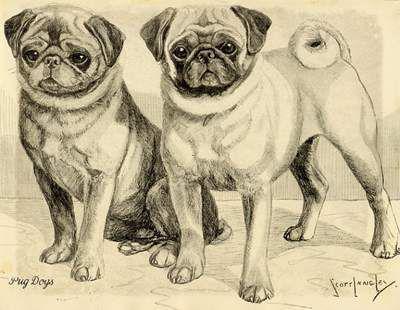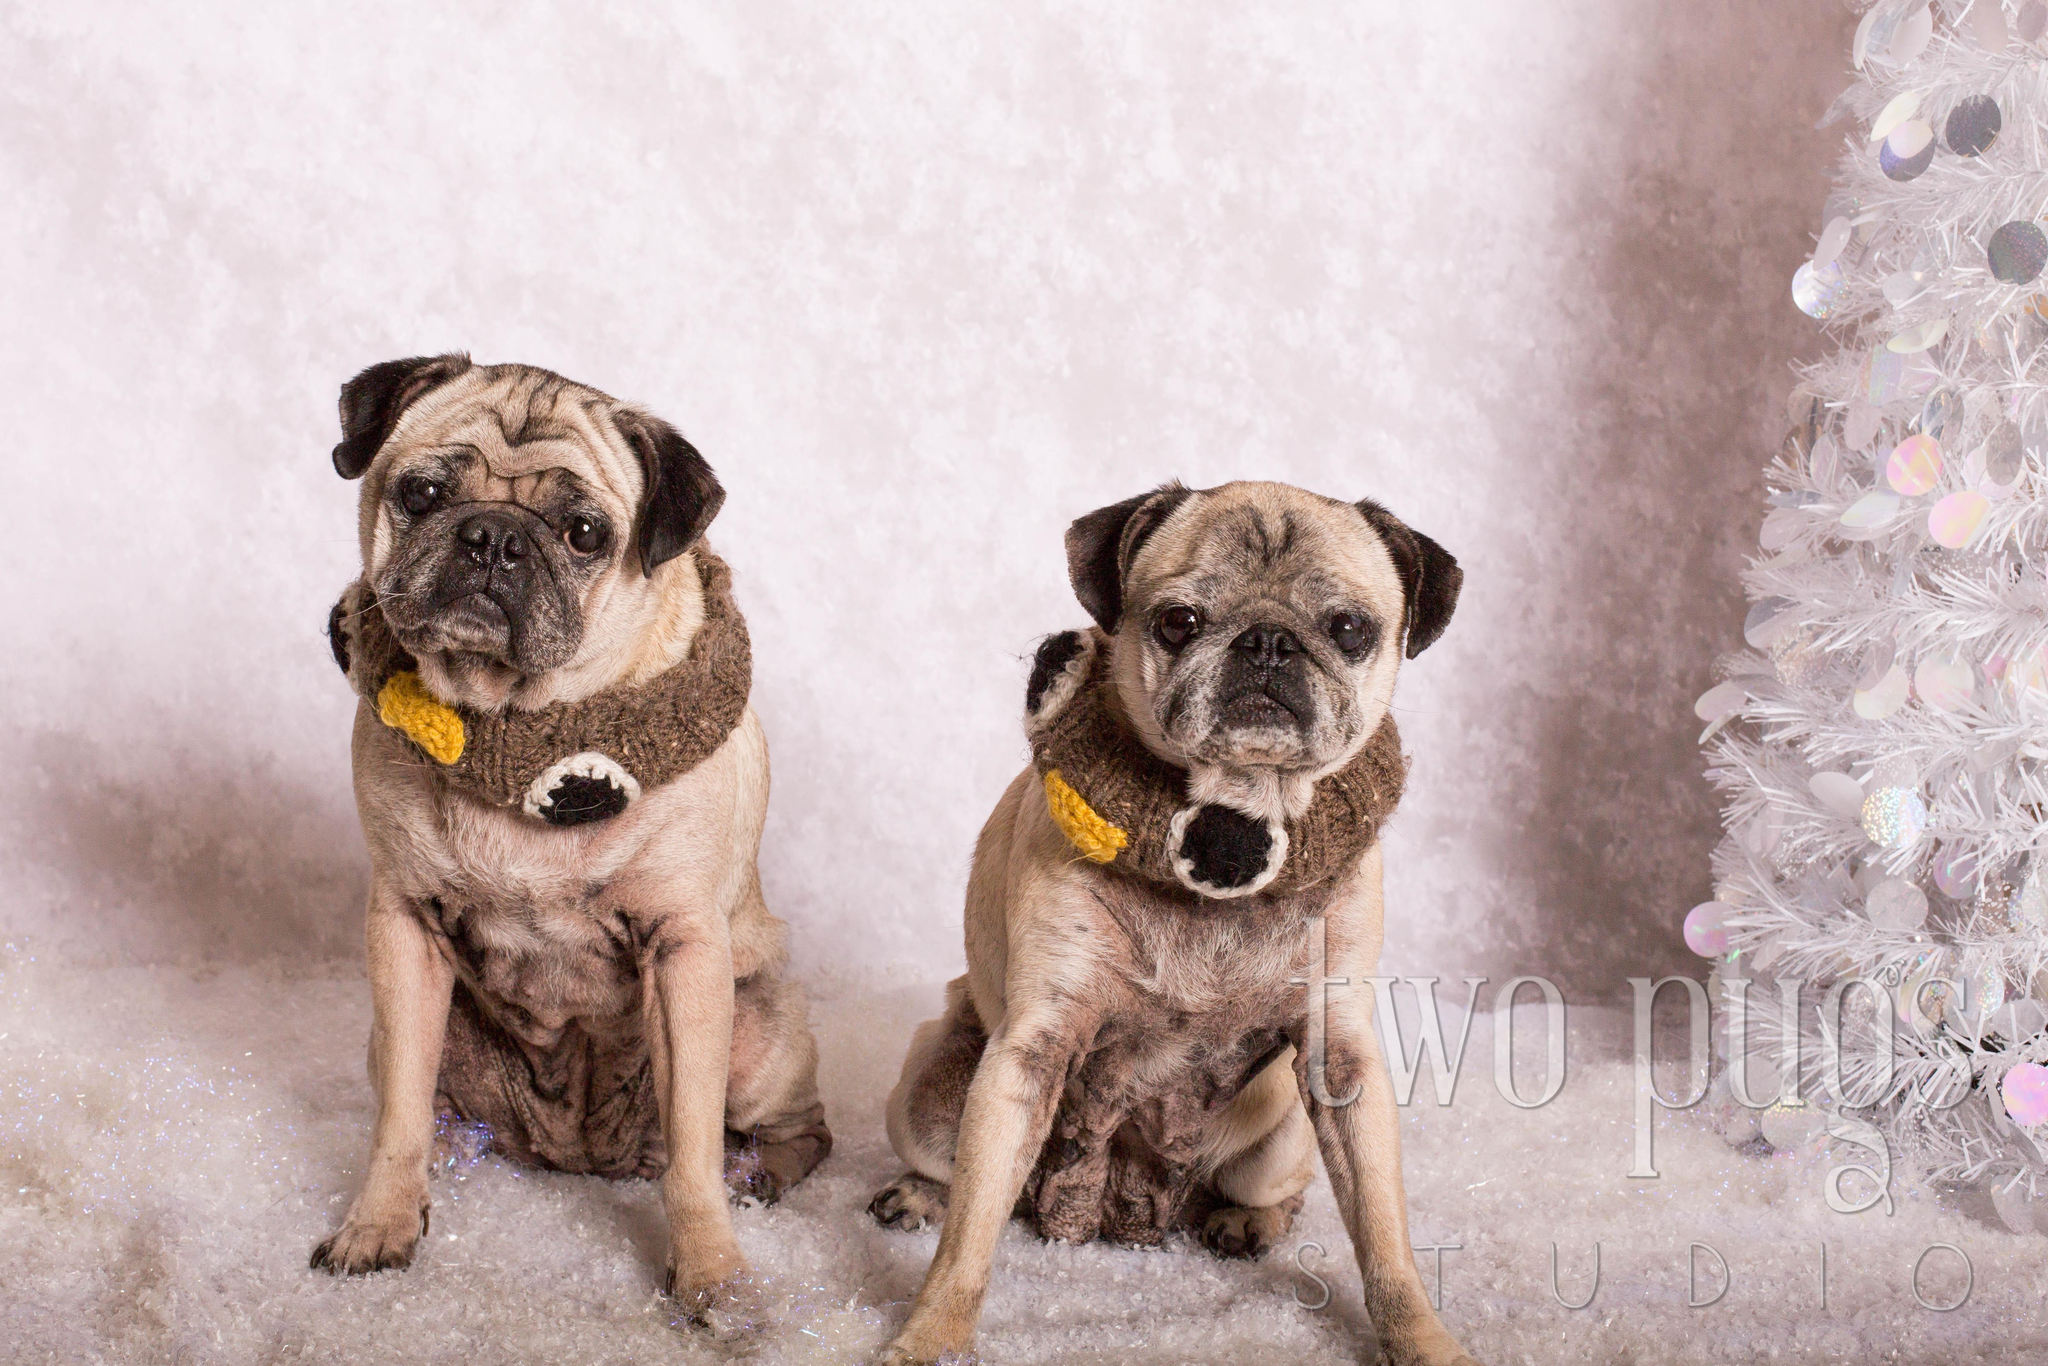The first image is the image on the left, the second image is the image on the right. Considering the images on both sides, is "The dog in the right image is wearing a harness." valid? Answer yes or no. No. The first image is the image on the left, the second image is the image on the right. Evaluate the accuracy of this statement regarding the images: "There is one bird next to a dog.". Is it true? Answer yes or no. No. 